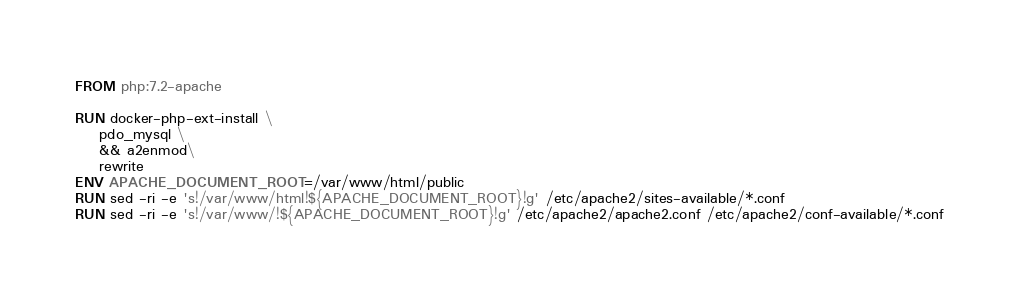<code> <loc_0><loc_0><loc_500><loc_500><_Dockerfile_>FROM php:7.2-apache

RUN docker-php-ext-install \
    pdo_mysql \
    && a2enmod\
    rewrite
ENV APACHE_DOCUMENT_ROOT=/var/www/html/public
RUN sed -ri -e 's!/var/www/html!${APACHE_DOCUMENT_ROOT}!g' /etc/apache2/sites-available/*.conf
RUN sed -ri -e 's!/var/www/!${APACHE_DOCUMENT_ROOT}!g' /etc/apache2/apache2.conf /etc/apache2/conf-available/*.conf</code> 